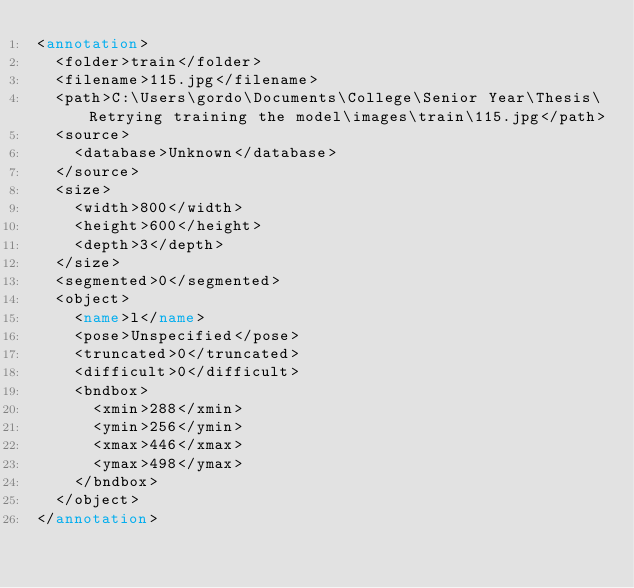Convert code to text. <code><loc_0><loc_0><loc_500><loc_500><_XML_><annotation>
	<folder>train</folder>
	<filename>115.jpg</filename>
	<path>C:\Users\gordo\Documents\College\Senior Year\Thesis\Retrying training the model\images\train\115.jpg</path>
	<source>
		<database>Unknown</database>
	</source>
	<size>
		<width>800</width>
		<height>600</height>
		<depth>3</depth>
	</size>
	<segmented>0</segmented>
	<object>
		<name>l</name>
		<pose>Unspecified</pose>
		<truncated>0</truncated>
		<difficult>0</difficult>
		<bndbox>
			<xmin>288</xmin>
			<ymin>256</ymin>
			<xmax>446</xmax>
			<ymax>498</ymax>
		</bndbox>
	</object>
</annotation>
</code> 